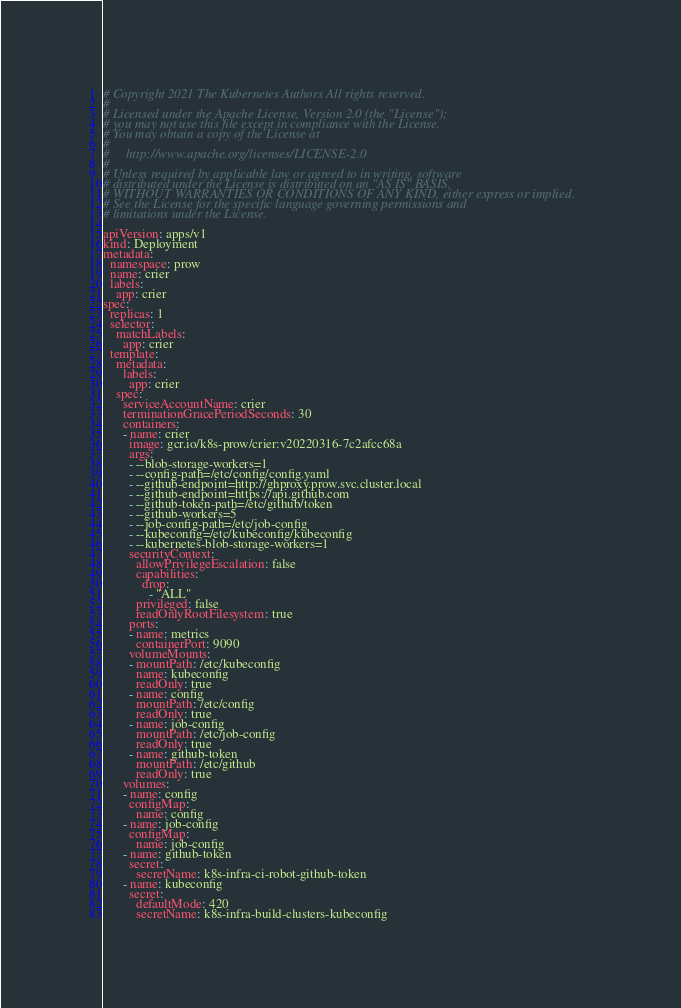Convert code to text. <code><loc_0><loc_0><loc_500><loc_500><_YAML_># Copyright 2021 The Kubernetes Authors All rights reserved.
#
# Licensed under the Apache License, Version 2.0 (the "License");
# you may not use this file except in compliance with the License.
# You may obtain a copy of the License at
#
#     http://www.apache.org/licenses/LICENSE-2.0
#
# Unless required by applicable law or agreed to in writing, software
# distributed under the License is distributed on an "AS IS" BASIS,
# WITHOUT WARRANTIES OR CONDITIONS OF ANY KIND, either express or implied.
# See the License for the specific language governing permissions and
# limitations under the License.

apiVersion: apps/v1
kind: Deployment
metadata:
  namespace: prow
  name: crier
  labels:
    app: crier
spec:
  replicas: 1
  selector:
    matchLabels:
      app: crier
  template:
    metadata:
      labels:
        app: crier
    spec:
      serviceAccountName: crier
      terminationGracePeriodSeconds: 30
      containers:
      - name: crier
        image: gcr.io/k8s-prow/crier:v20220316-7c2afcc68a
        args:
        - --blob-storage-workers=1
        - --config-path=/etc/config/config.yaml
        - --github-endpoint=http://ghproxy.prow.svc.cluster.local
        - --github-endpoint=https://api.github.com
        - --github-token-path=/etc/github/token
        - --github-workers=5
        - --job-config-path=/etc/job-config
        - --kubeconfig=/etc/kubeconfig/kubeconfig
        - --kubernetes-blob-storage-workers=1
        securityContext:
          allowPrivilegeEscalation: false
          capabilities:
            drop:
              - "ALL"
          privileged: false
          readOnlyRootFilesystem: true
        ports:
        - name: metrics
          containerPort: 9090
        volumeMounts:
        - mountPath: /etc/kubeconfig
          name: kubeconfig
          readOnly: true
        - name: config
          mountPath: /etc/config
          readOnly: true
        - name: job-config
          mountPath: /etc/job-config
          readOnly: true
        - name: github-token
          mountPath: /etc/github
          readOnly: true
      volumes:
      - name: config
        configMap:
          name: config
      - name: job-config
        configMap:
          name: job-config
      - name: github-token
        secret:
          secretName: k8s-infra-ci-robot-github-token
      - name: kubeconfig
        secret:
          defaultMode: 420
          secretName: k8s-infra-build-clusters-kubeconfig
</code> 